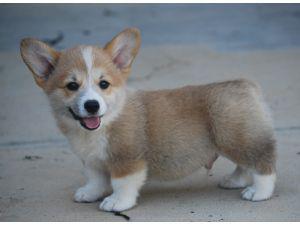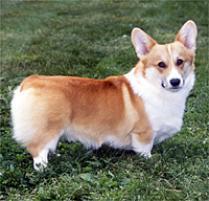The first image is the image on the left, the second image is the image on the right. For the images displayed, is the sentence "The dog in the left image is standing on all four legs with its body pointing left." factually correct? Answer yes or no. Yes. The first image is the image on the left, the second image is the image on the right. Evaluate the accuracy of this statement regarding the images: "The image on the right shows a corgi puppy in movement and the left one shows a corgi puppy sitting down.". Is it true? Answer yes or no. No. 